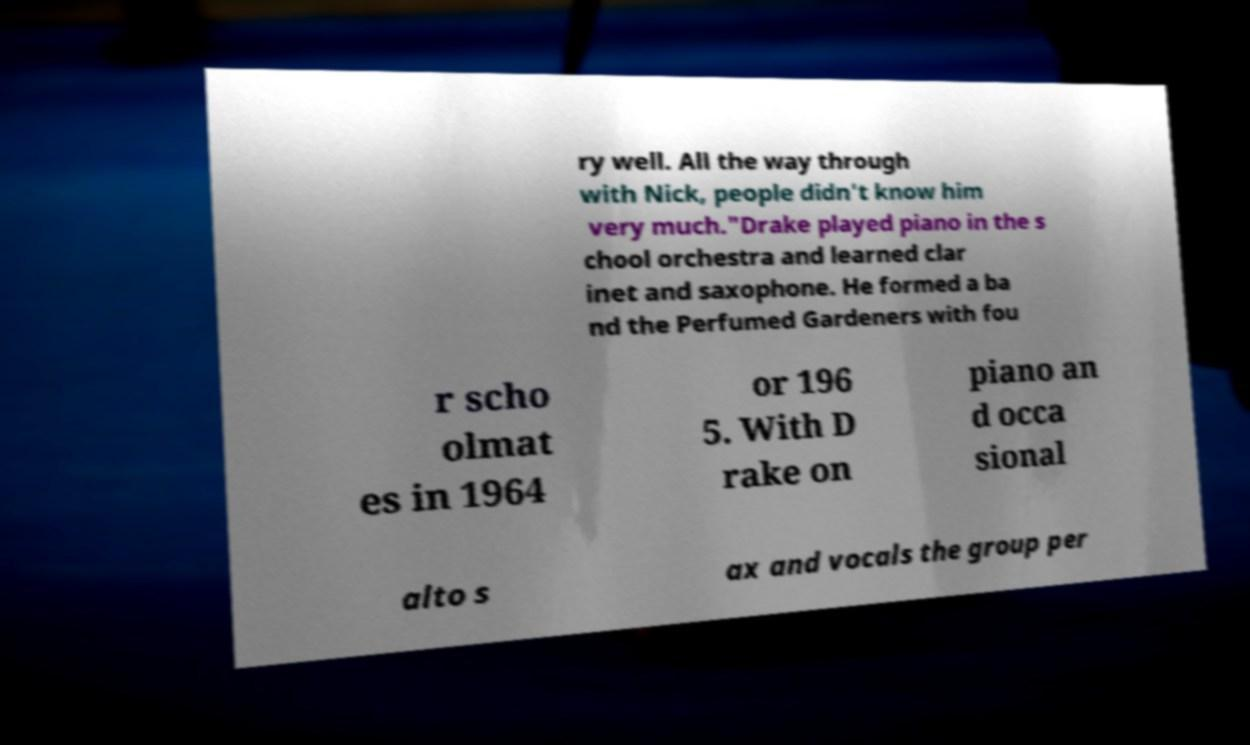I need the written content from this picture converted into text. Can you do that? ry well. All the way through with Nick, people didn't know him very much."Drake played piano in the s chool orchestra and learned clar inet and saxophone. He formed a ba nd the Perfumed Gardeners with fou r scho olmat es in 1964 or 196 5. With D rake on piano an d occa sional alto s ax and vocals the group per 